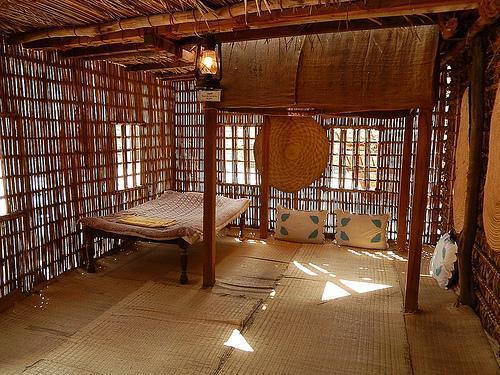How many beds are there?
Give a very brief answer. 1. 